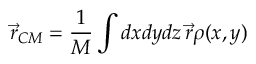<formula> <loc_0><loc_0><loc_500><loc_500>\vec { r } _ { C M } = \frac { 1 } { M } \int d x d y d z \, \vec { r } \rho ( x , y )</formula> 